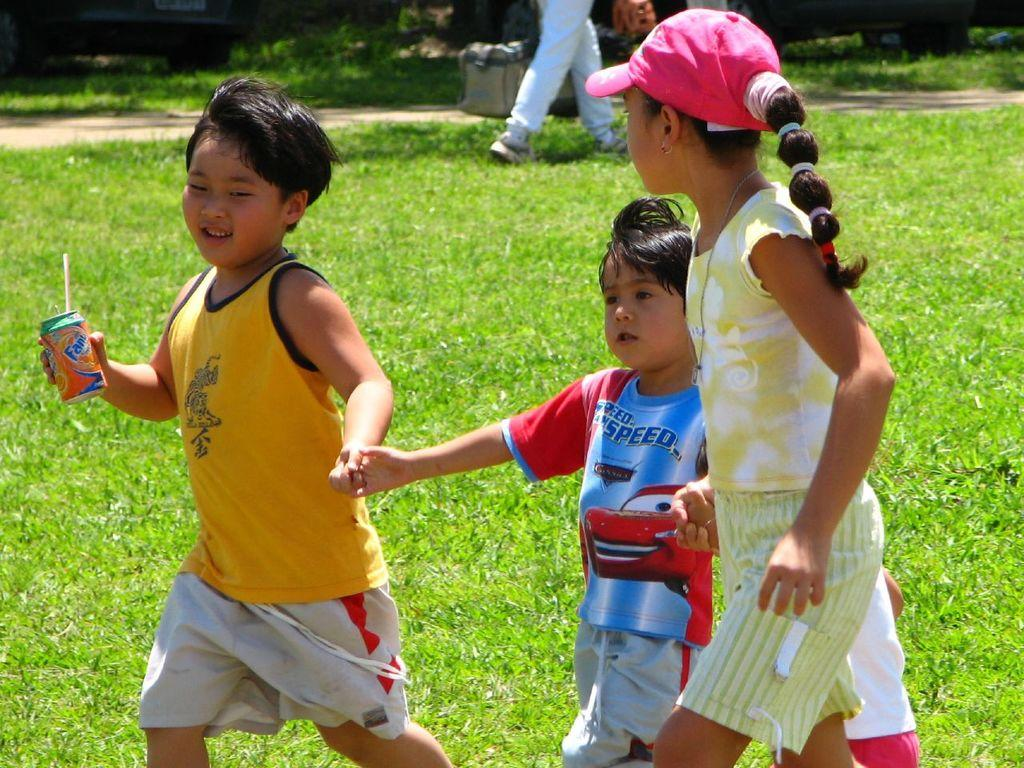How many children are in the foreground of the image? There are three children in the foreground of the image. What is one of the children holding? One of the children is holding a coke tin. Can you describe any other visible elements in the image? There are another person's legs visible at the top of the image. What type of bridge can be seen in the background of the image? There is no bridge visible in the image. Is there a drum being played by any of the children in the image? There is no drum present in the image. 